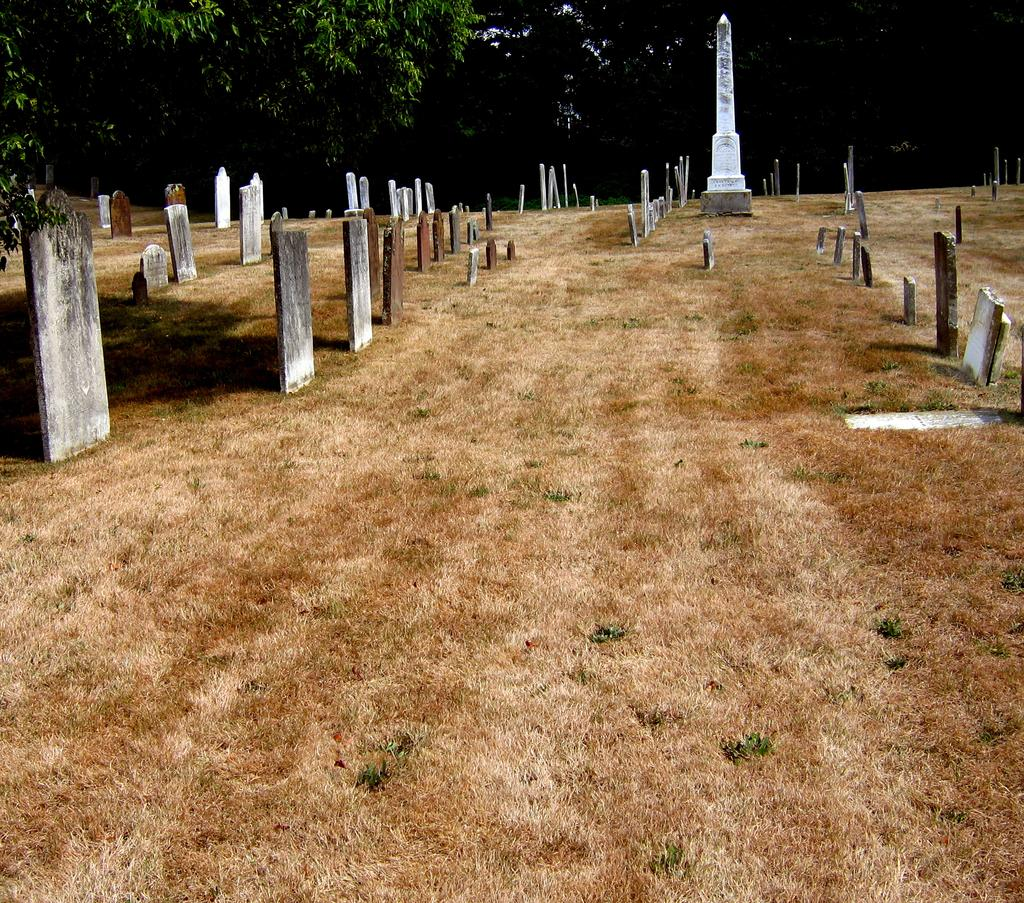What can be seen in the image that represents a place of burial? There are graves in the image. What is located on the ground in the image? There is a memorial on the ground in the image. What type of natural environment is visible in the background of the image? There are trees visible in the background of the image. Where is the sofa placed in the image? There is no sofa present in the image. What type of rodent can be seen scurrying near the graves in the image? There are no rodents visible in the image. 